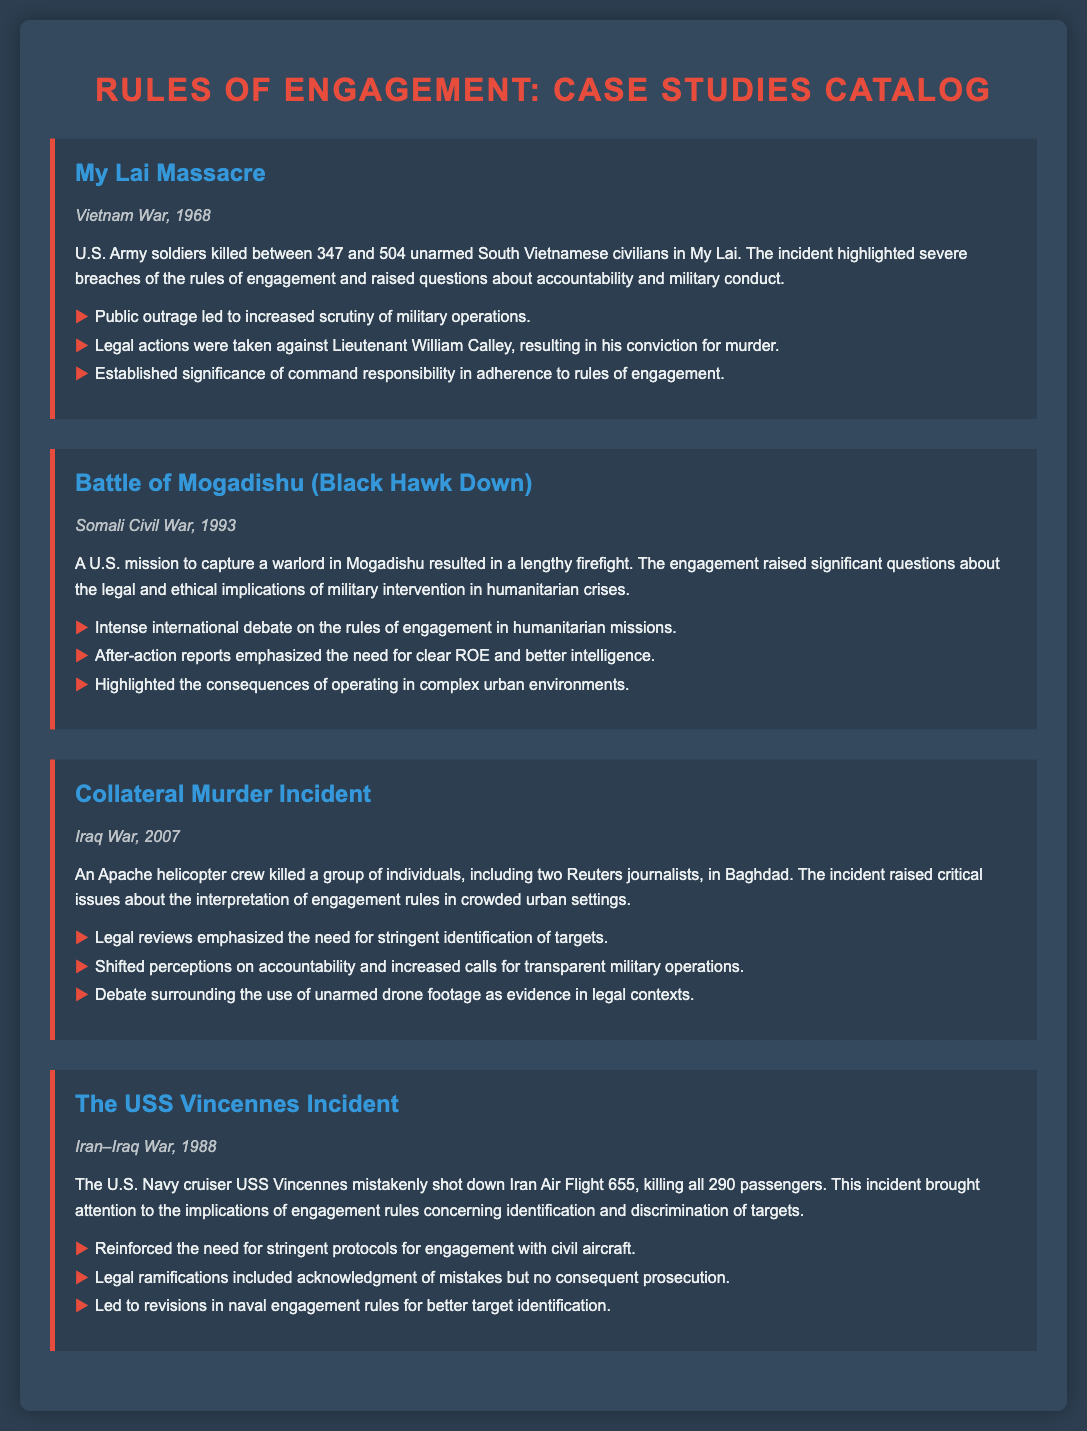What year did the My Lai Massacre occur? The My Lai Massacre occurred in Vietnam War in 1968.
Answer: 1968 What incident took place during the Somali Civil War? The incident that took place was the Battle of Mogadishu, also known as Black Hawk Down.
Answer: Battle of Mogadishu Which aircraft was mistakenly shot down by the USS Vincennes? The USS Vincennes mistakenly shot down Iran Air Flight 655.
Answer: Iran Air Flight 655 What are the key legal implications highlighted by the Collateral Murder incident? The key legal implications include the need for stringent identification of targets.
Answer: Stringent identification of targets Who was convicted for murder related to the My Lai Massacre? Lieutenant William Calley was convicted for murder.
Answer: Lieutenant William Calley What significant outcome emerged from the Battle of Mogadishu's after-action reports? The significant outcome was the emphasis on the need for clear ROE and better intelligence.
Answer: Clear ROE and better intelligence What was the primary focus of the legal ramifications in the USS Vincennes incident? The primary focus was acknowledgment of mistakes without consequent prosecution.
Answer: Acknowledgment of mistakes Which year did the Collateral Murder incident occur? The Collateral Murder incident occurred in the year 2007.
Answer: 2007 